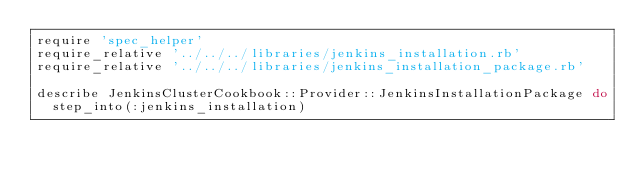Convert code to text. <code><loc_0><loc_0><loc_500><loc_500><_Ruby_>require 'spec_helper'
require_relative '../../../libraries/jenkins_installation.rb'
require_relative '../../../libraries/jenkins_installation_package.rb'

describe JenkinsClusterCookbook::Provider::JenkinsInstallationPackage do
  step_into(:jenkins_installation)</code> 